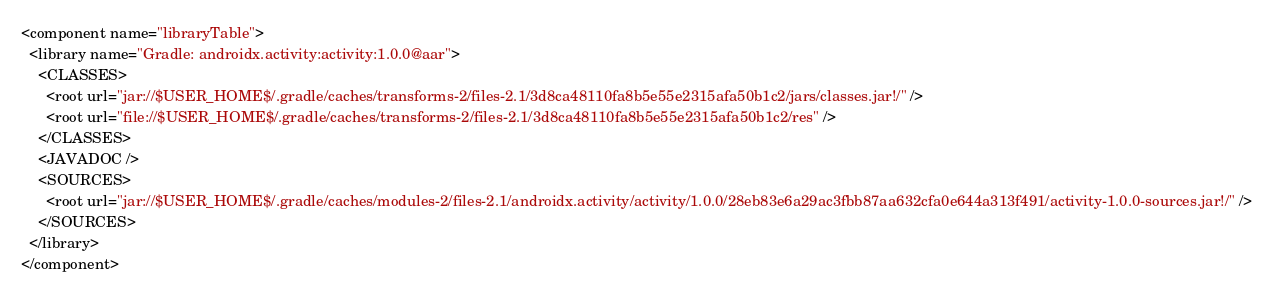Convert code to text. <code><loc_0><loc_0><loc_500><loc_500><_XML_><component name="libraryTable">
  <library name="Gradle: androidx.activity:activity:1.0.0@aar">
    <CLASSES>
      <root url="jar://$USER_HOME$/.gradle/caches/transforms-2/files-2.1/3d8ca48110fa8b5e55e2315afa50b1c2/jars/classes.jar!/" />
      <root url="file://$USER_HOME$/.gradle/caches/transforms-2/files-2.1/3d8ca48110fa8b5e55e2315afa50b1c2/res" />
    </CLASSES>
    <JAVADOC />
    <SOURCES>
      <root url="jar://$USER_HOME$/.gradle/caches/modules-2/files-2.1/androidx.activity/activity/1.0.0/28eb83e6a29ac3fbb87aa632cfa0e644a313f491/activity-1.0.0-sources.jar!/" />
    </SOURCES>
  </library>
</component></code> 